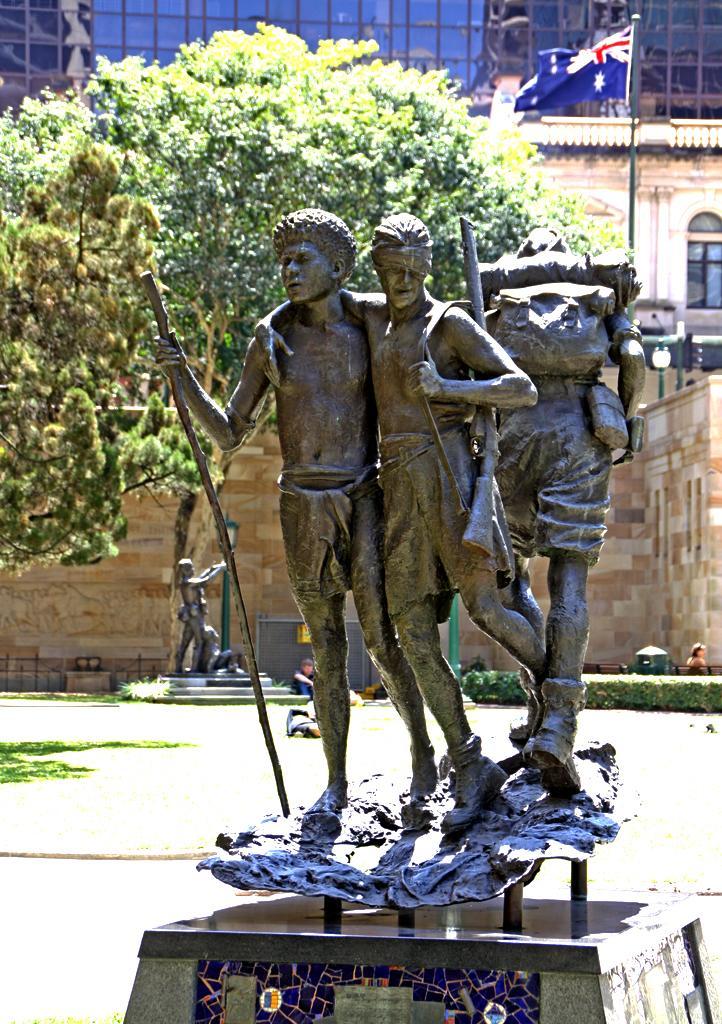In one or two sentences, can you explain what this image depicts? In this image I can see the statue of few persons standing and holding sticks in their hands. In the background I can see another statue of a person, a tree, few buildings, a flag and few persons. 